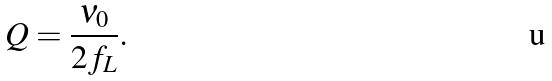Convert formula to latex. <formula><loc_0><loc_0><loc_500><loc_500>Q & = \frac { \nu _ { 0 } } { 2 f _ { L } } .</formula> 